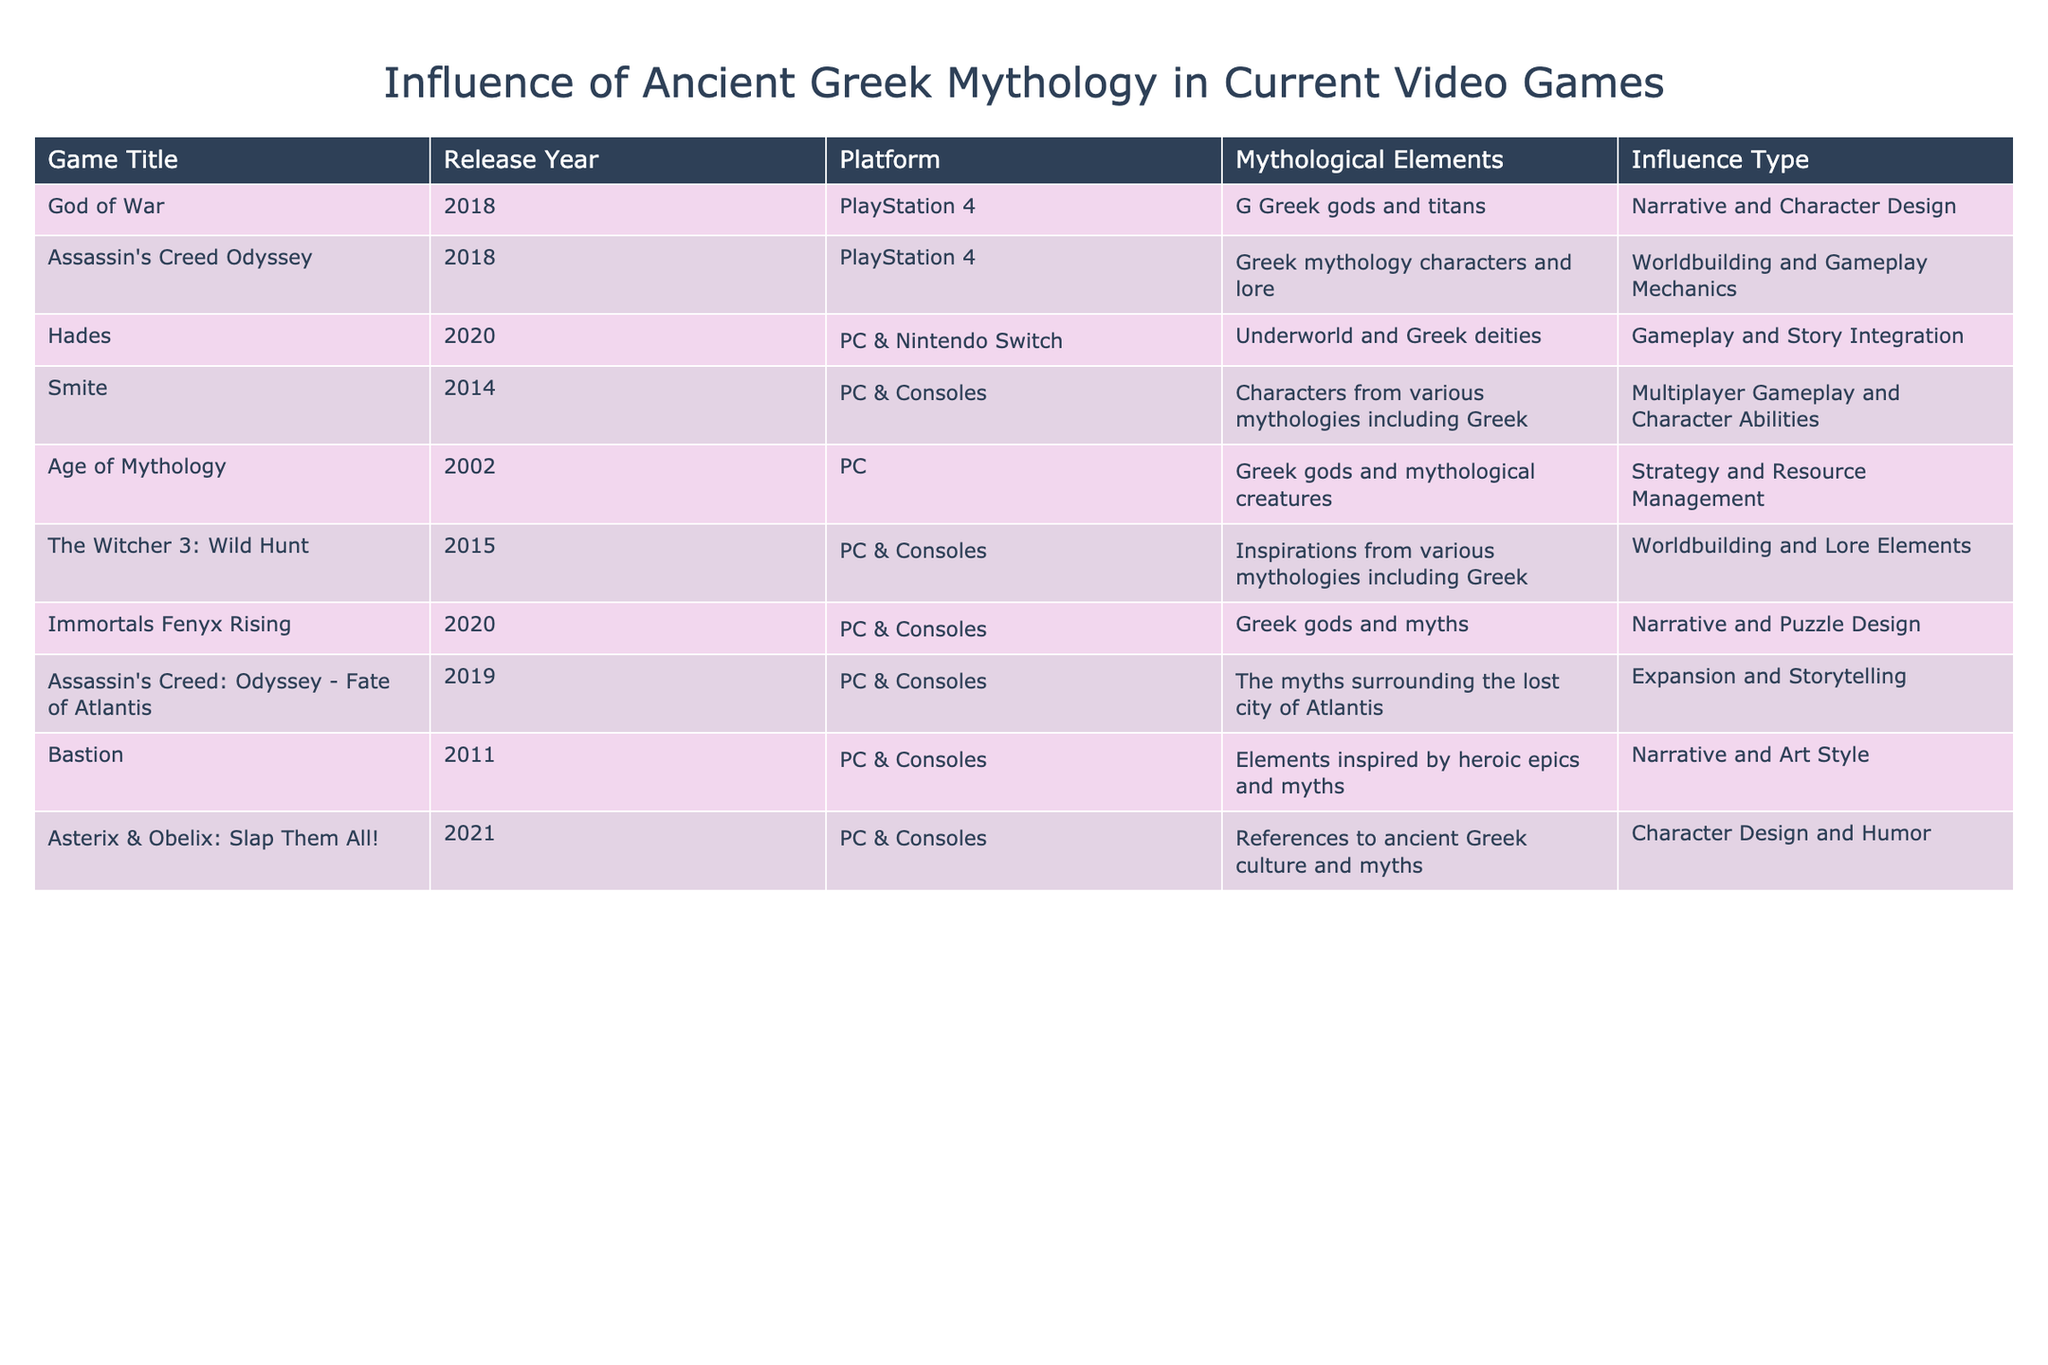What is the release year of "Hades"? The table lists the release year under the "Release Year" column for each game. For "Hades," it shows the year is 2020.
Answer: 2020 Which game features Greek gods and titans as mythological elements? By looking at the "Mythological Elements" column, "God of War" specifically mentions Greek gods and titans.
Answer: God of War Are there more games that include worldbuilding influences or gameplay influences? Summing up the influences in the "Influence Type" column, there are 4 games categorized under worldbuilding (Assassin's Creed Odyssey, The Witcher 3: Wild Hunt, Immortals Fenyx Rising, and Assassin's Creed: Odyssey - Fate of Atlantis) and 4 games categorized under gameplay influences (Hades, Smite, Assassin's Creed: Odyssey - Fate of Atlantis, and Immortals Fenyx Rising). Thus, they are equal.
Answer: They are equal Do both "Smite" and "Age of Mythology" feature Greek mythological elements? Checking the "Mythological Elements" for both games: "Smite" includes characters from various mythologies including Greek, while "Age of Mythology" specifically mentions Greek gods and mythological creatures. Therefore, both incorporate elements from Greek mythology.
Answer: Yes Which game released in 2018 includes gameplay and story integration related to Greek mythology? Looking at the release year and the influence type, "Hades" is the only game released in 2018 that emphasizes gameplay and story integration related to Greek mythology.Therefore, it meets the criteria.
Answer: Hades What percentage of the games involve characters from ancient Greek culture? There are 10 games listed in total, and 6 of them include characters from ancient Greek culture (God of War, Assassin's Creed Odyssey, Hades, Smite, Immortals Fenyx Rising, and Asterix & Obelix: Slap Them All!). To find the percentage, divide 6 by 10, which equals 0.6, and then multiply by 100 to get 60%.
Answer: 60% How many games mention narrative as an influence type? Upon examining the "Influence Type" column, the games that mention narrative as an influence type include God of War, Immortals Fenyx Rising, and Bastion, totaling 3 games.
Answer: 3 In terms of character design, how many games focus on Greek myths? Looking at the "Mythological Elements" and "Influence Type" together, there are 4 games that focus on character design with Greek themes: God of War, Asterix & Obelix: Slap Them All!, Immortals Fenyx Rising, and Hades. This gives us the total.
Answer: 4 